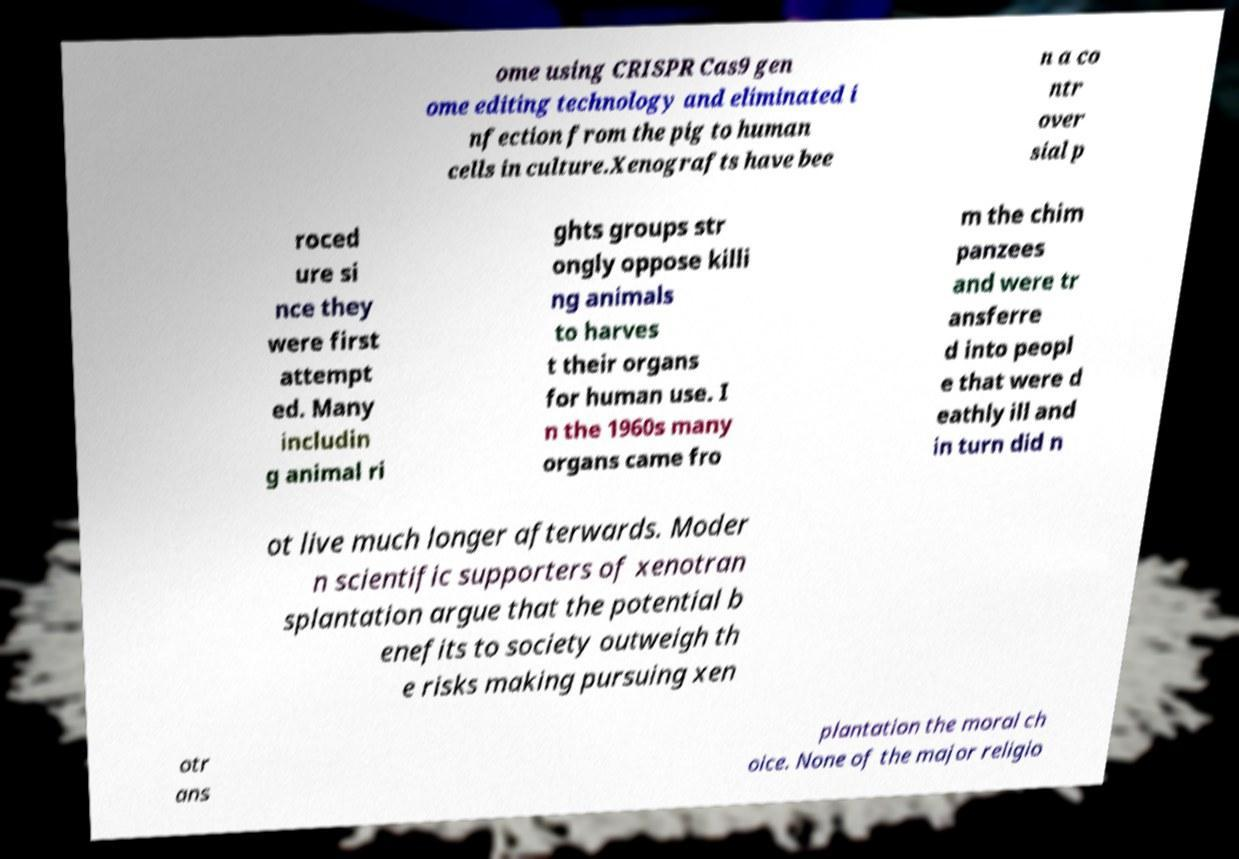Could you extract and type out the text from this image? ome using CRISPR Cas9 gen ome editing technology and eliminated i nfection from the pig to human cells in culture.Xenografts have bee n a co ntr over sial p roced ure si nce they were first attempt ed. Many includin g animal ri ghts groups str ongly oppose killi ng animals to harves t their organs for human use. I n the 1960s many organs came fro m the chim panzees and were tr ansferre d into peopl e that were d eathly ill and in turn did n ot live much longer afterwards. Moder n scientific supporters of xenotran splantation argue that the potential b enefits to society outweigh th e risks making pursuing xen otr ans plantation the moral ch oice. None of the major religio 